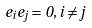Convert formula to latex. <formula><loc_0><loc_0><loc_500><loc_500>e _ { i } e _ { j } = 0 , i \neq j</formula> 